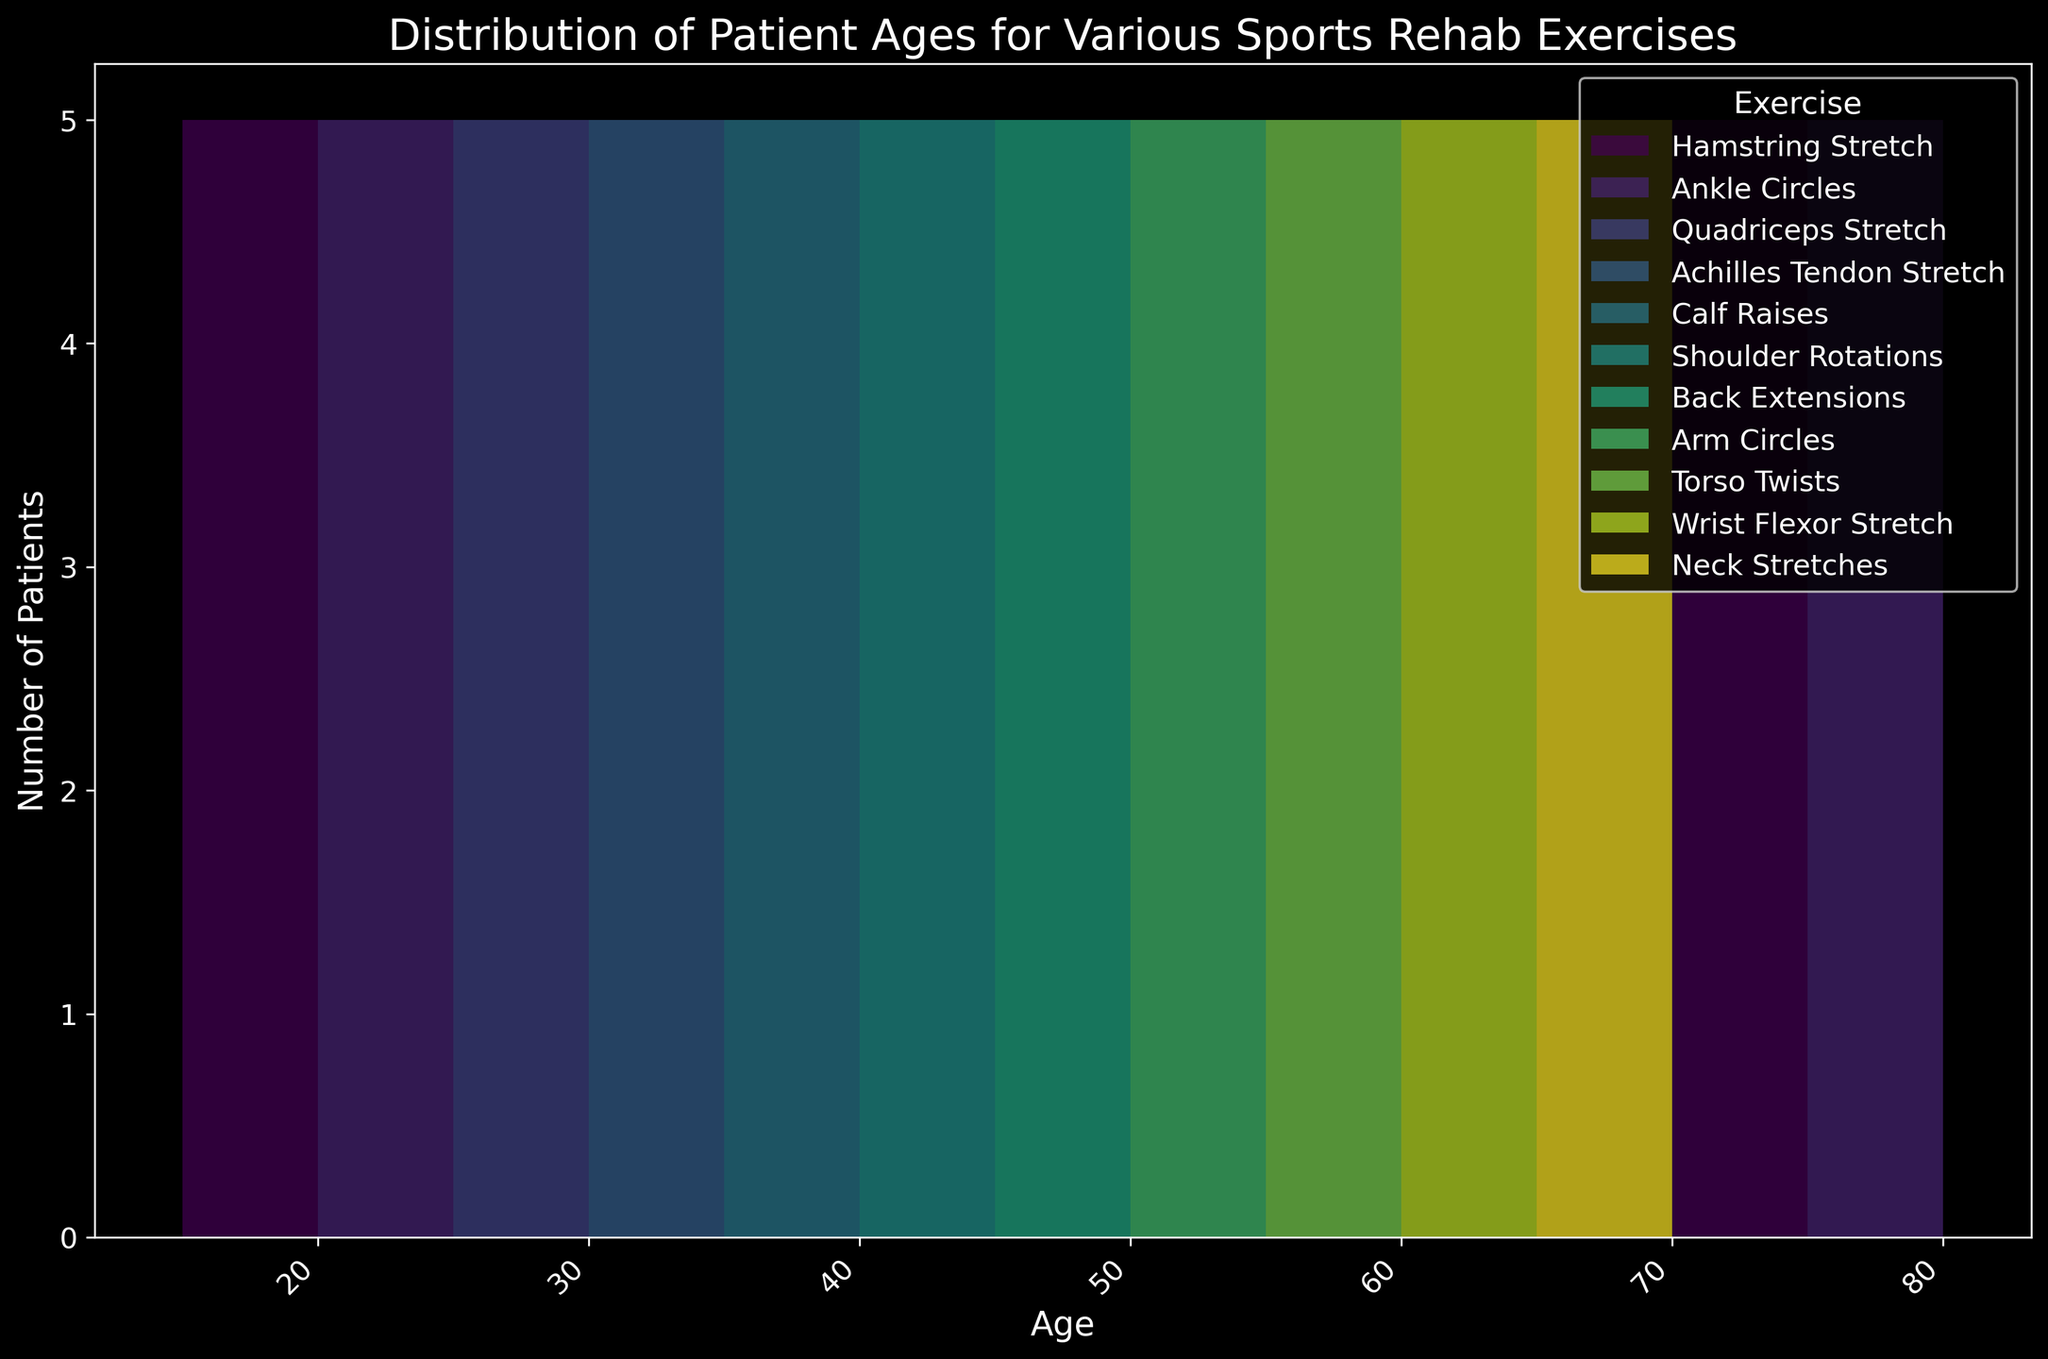What is the most common age range for Hamstring Stretch exercises? By looking at the histogram, the highest bar for the Hamstring Stretch exercises falls within the age range of 15-20 and 70-75. This shows that these two age groups have the most number of patients doing Hamstring Stretch exercises.
Answer: 15-20 and 70-75 Which exercise has the widest age range of patients? By observing the horizontal span of colored bars for each exercise, it’s noticeable that Hamstring Stretch exercises cover the widest age range, from ages 15 to 20 and again from 70 to 75, making it the exercise with the widest age range.
Answer: Hamstring Stretch Which exercises are primarily performed by patients aged 40-45? To answer this, focus on which segments (colors) dominate the bars within the age range 40-45 on the x-axis. This range is mostly covered by Shoulder Rotations, indicating it’s the primary exercise for this age group.
Answer: Shoulder Rotations Is there an exercise that spans two distinct age ranges? By noting the exercises that have bars at non-contiguous age ranges, Hamstring Stretch is visible in both the younger age range (15-20) and older age range (70-75), indicating two distinct age ranges.
Answer: Hamstring Stretch Which exercise does the oldest patient in the dataset perform? The oldest patient age in the histogram is 79. By identifying the exercise done at age 79, we see that the exercise is Ankle Circles.
Answer: Ankle Circles How many different exercises do patients aged 30-35 perform? By counting the distinct colored bars within the 30-35 age range, the exercises performed are Achilles Tendon Stretch and Calf Raises, amounting to two different exercises.
Answer: 2 Between Quadriceps Stretch and Calf Raises, which age range has the most overlap? By examining the colored bars that represent Quadriceps Stretch and Calf Raises, we find the overlapping age range of 25-30. Both exercises have bars in this age range.
Answer: 25-30 What is the average age range of patients doing Arm Circles? To find the average, we compute the midpoints of the age ranges where Arm Circles appears (50-54). So, the midpoint is (50+54)/2 = 52.
Answer: 52 Which exercise has the least variation in the patients' age range? The exercise with bars concentrated closely around a particular age range will show the least age variation. Here, Back Extensions appears only within the 45-49 age range.
Answer: Back Extensions 